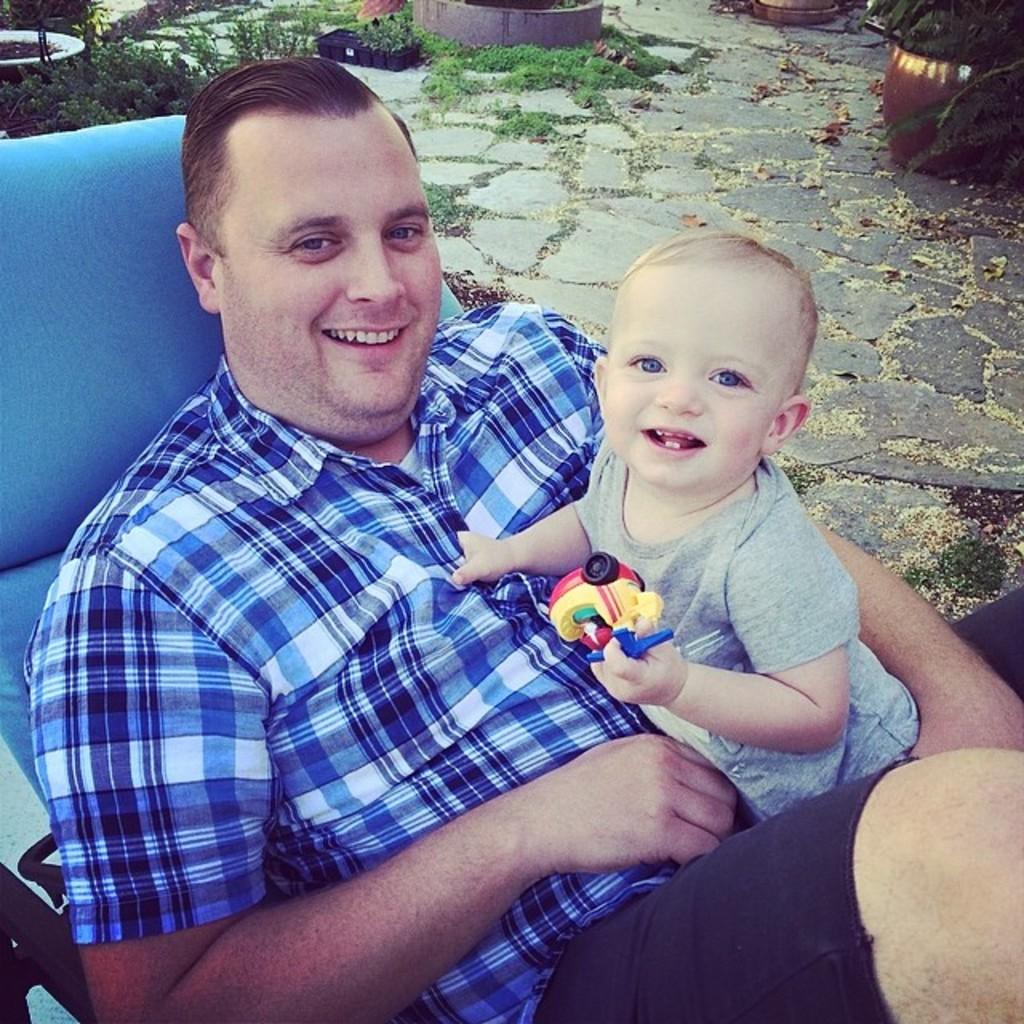What is the person in the image wearing? The person is wearing a blue shirt in the image. What is the person doing in the image? The person is sitting on a chair in the image. Who else is present in the image? There is a child in the image. What is the child holding? The child is holding a toy in the image. What can be seen in the background of the image? There is grass and a pot in the background of the image. How many oranges are visible in the image? There are no oranges present in the image. What type of drawer can be seen in the image? There is no drawer present in the image. 